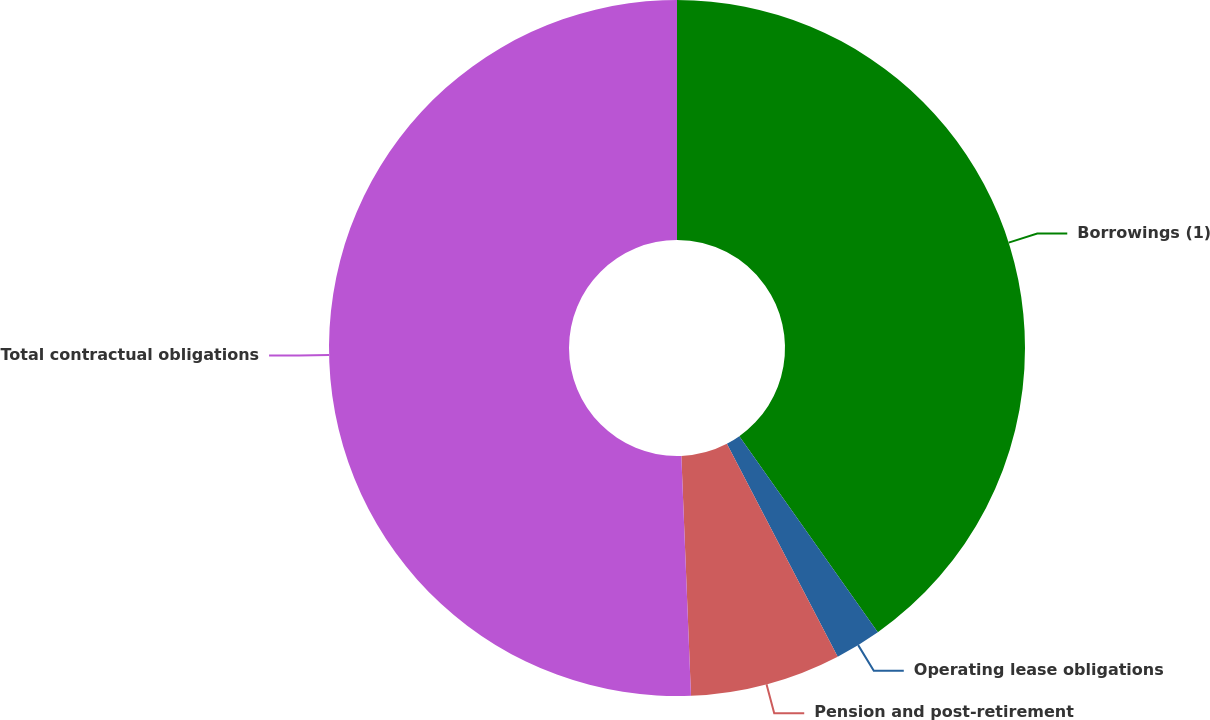Convert chart to OTSL. <chart><loc_0><loc_0><loc_500><loc_500><pie_chart><fcel>Borrowings (1)<fcel>Operating lease obligations<fcel>Pension and post-retirement<fcel>Total contractual obligations<nl><fcel>40.21%<fcel>2.15%<fcel>7.0%<fcel>50.64%<nl></chart> 